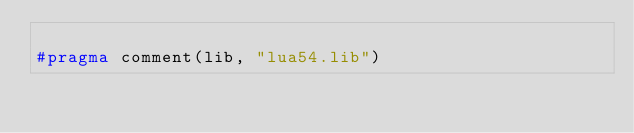Convert code to text. <code><loc_0><loc_0><loc_500><loc_500><_C++_>
#pragma comment(lib, "lua54.lib")
</code> 